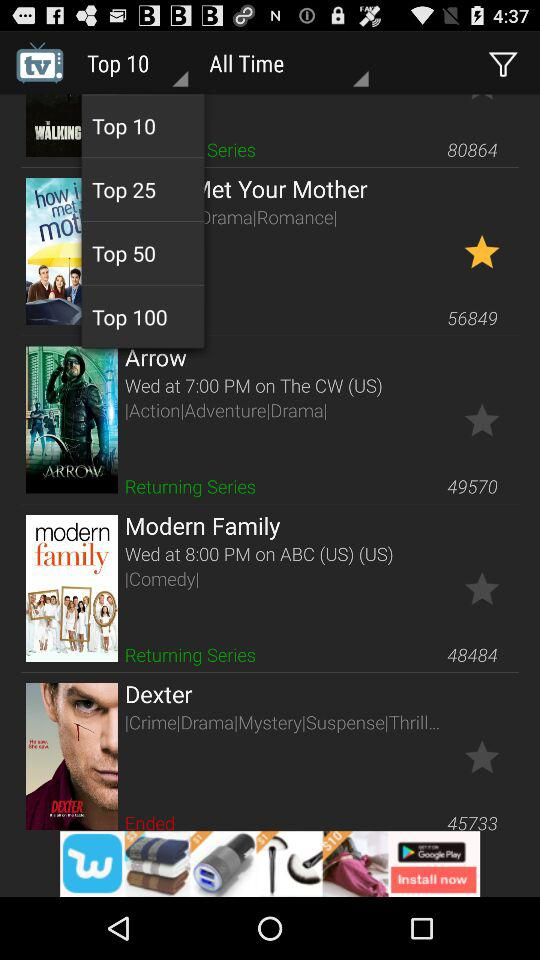When was the "Modern Family" released? The "Modern Family" was released on Wednesday at 8:00 pm. 